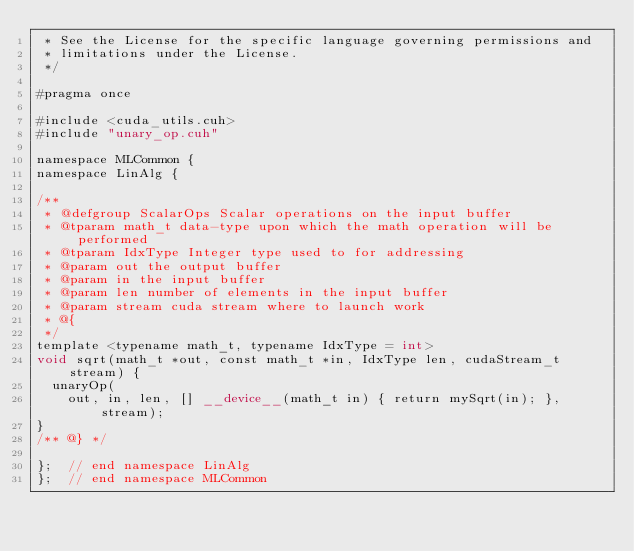Convert code to text. <code><loc_0><loc_0><loc_500><loc_500><_Cuda_> * See the License for the specific language governing permissions and
 * limitations under the License.
 */

#pragma once

#include <cuda_utils.cuh>
#include "unary_op.cuh"

namespace MLCommon {
namespace LinAlg {

/**
 * @defgroup ScalarOps Scalar operations on the input buffer
 * @tparam math_t data-type upon which the math operation will be performed
 * @tparam IdxType Integer type used to for addressing
 * @param out the output buffer
 * @param in the input buffer
 * @param len number of elements in the input buffer
 * @param stream cuda stream where to launch work
 * @{
 */
template <typename math_t, typename IdxType = int>
void sqrt(math_t *out, const math_t *in, IdxType len, cudaStream_t stream) {
  unaryOp(
    out, in, len, [] __device__(math_t in) { return mySqrt(in); }, stream);
}
/** @} */

};  // end namespace LinAlg
};  // end namespace MLCommon
</code> 